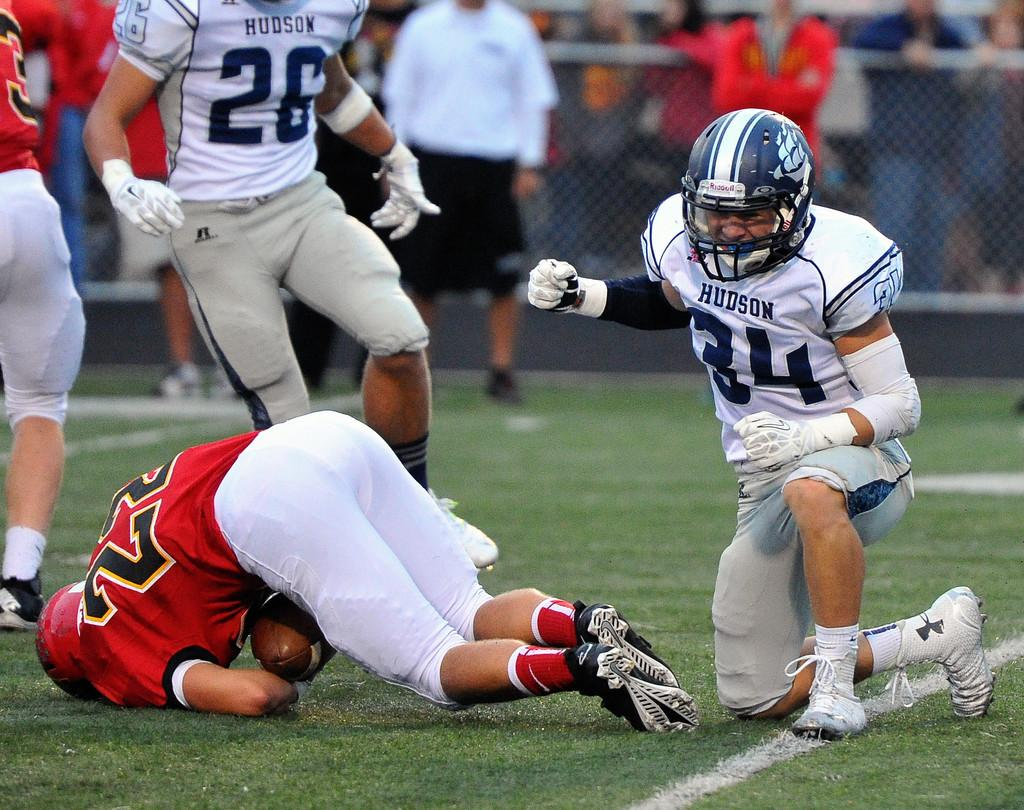What sport are the persons playing in the image? The persons are playing baseball in the image. Where is the baseball game taking place? The baseball game is taking place on the ground. What can be seen in the background of the image? There is a metal net and persons standing in the background of the image. What type of coat is the lead wearing during the meeting in the image? There is no meeting or lead present in the image, and no one is wearing a coat. 